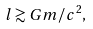Convert formula to latex. <formula><loc_0><loc_0><loc_500><loc_500>l \gtrsim G m / c ^ { 2 } ,</formula> 